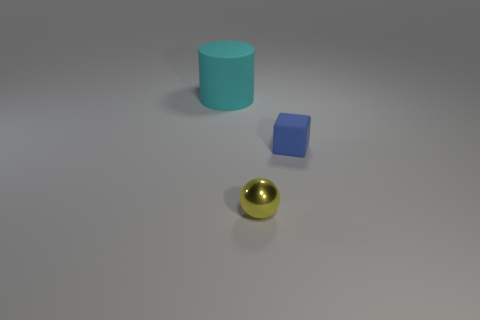Add 1 cyan matte things. How many objects exist? 4 Subtract all red cylinders. How many cyan cubes are left? 0 Add 3 matte cylinders. How many matte cylinders are left? 4 Add 2 red metallic cylinders. How many red metallic cylinders exist? 2 Subtract 0 cyan blocks. How many objects are left? 3 Subtract all balls. How many objects are left? 2 Subtract 1 cubes. How many cubes are left? 0 Subtract all green cylinders. Subtract all gray spheres. How many cylinders are left? 1 Subtract all blue matte things. Subtract all cylinders. How many objects are left? 1 